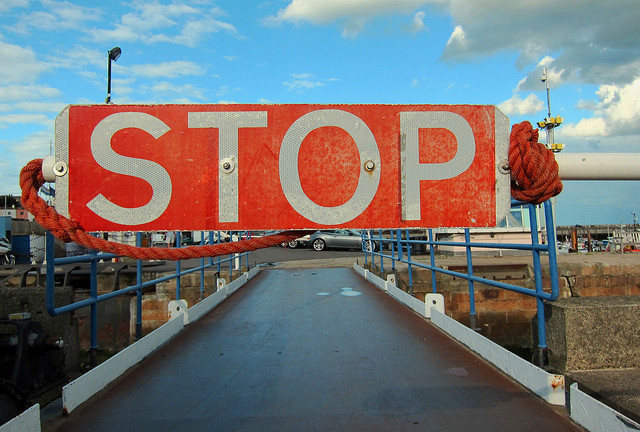How many people are riding the bike farthest to the left? Based on the image provided, there are no people riding any bikes, as the image shows a stop sign at the entrance of a bridge or dock, with no bicycles in sight. 